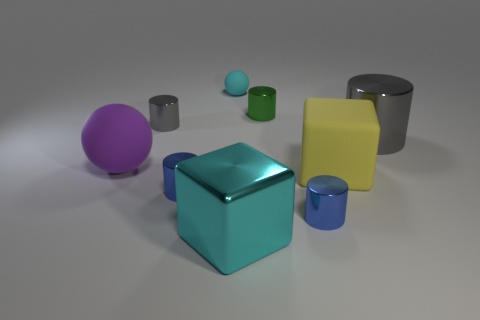There is another sphere that is made of the same material as the purple ball; what size is it?
Provide a short and direct response. Small. Is the cyan object in front of the big purple sphere made of the same material as the gray cylinder in front of the small gray object?
Make the answer very short. Yes. How many cylinders are either rubber objects or big things?
Ensure brevity in your answer.  1. How many large cylinders are in front of the large block to the right of the small blue cylinder that is to the right of the cyan cube?
Ensure brevity in your answer.  0. What material is the large cyan thing that is the same shape as the yellow object?
Offer a very short reply. Metal. Is there any other thing that has the same material as the purple sphere?
Provide a succinct answer. Yes. There is a big metallic object on the left side of the big gray cylinder; what is its color?
Give a very brief answer. Cyan. Does the green thing have the same material as the cylinder that is on the right side of the yellow rubber thing?
Your response must be concise. Yes. What material is the small cyan object?
Your answer should be compact. Rubber. There is a gray object that is made of the same material as the large gray cylinder; what shape is it?
Your answer should be very brief. Cylinder. 